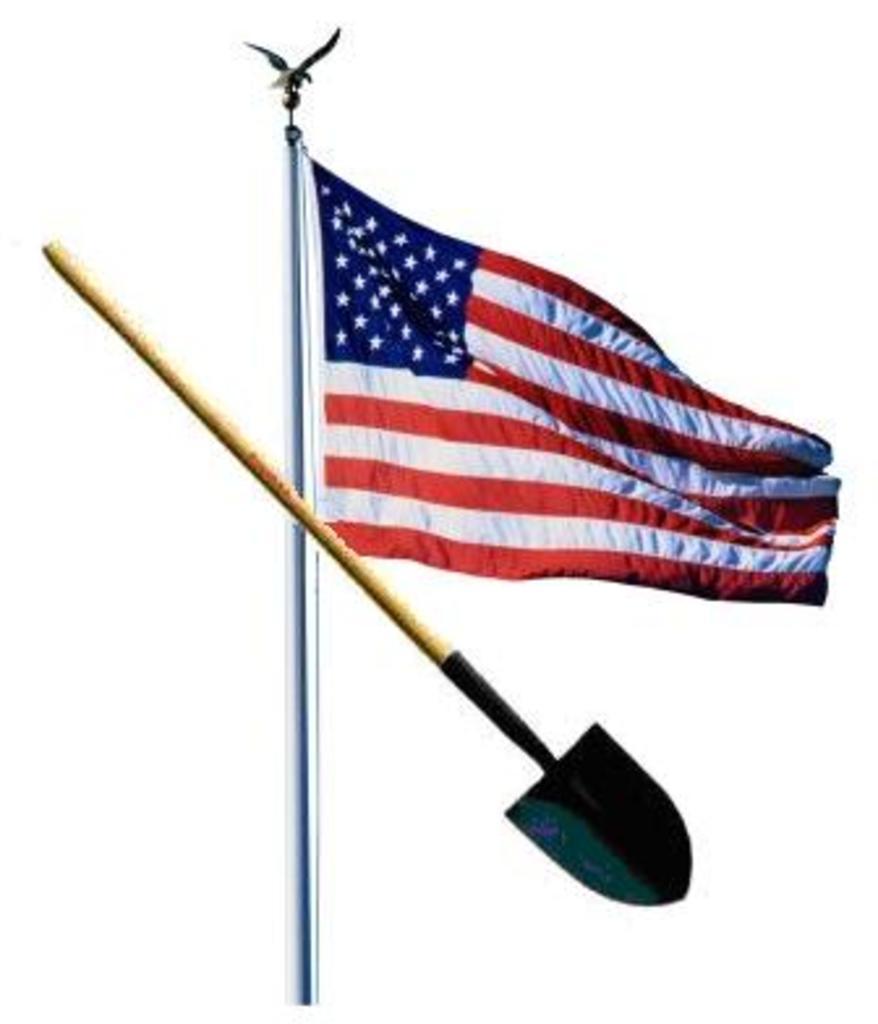In one or two sentences, can you explain what this image depicts? In this image I can see the mud digger and the flag. The flag is in red, white and navy blue color. And there is a white background. 